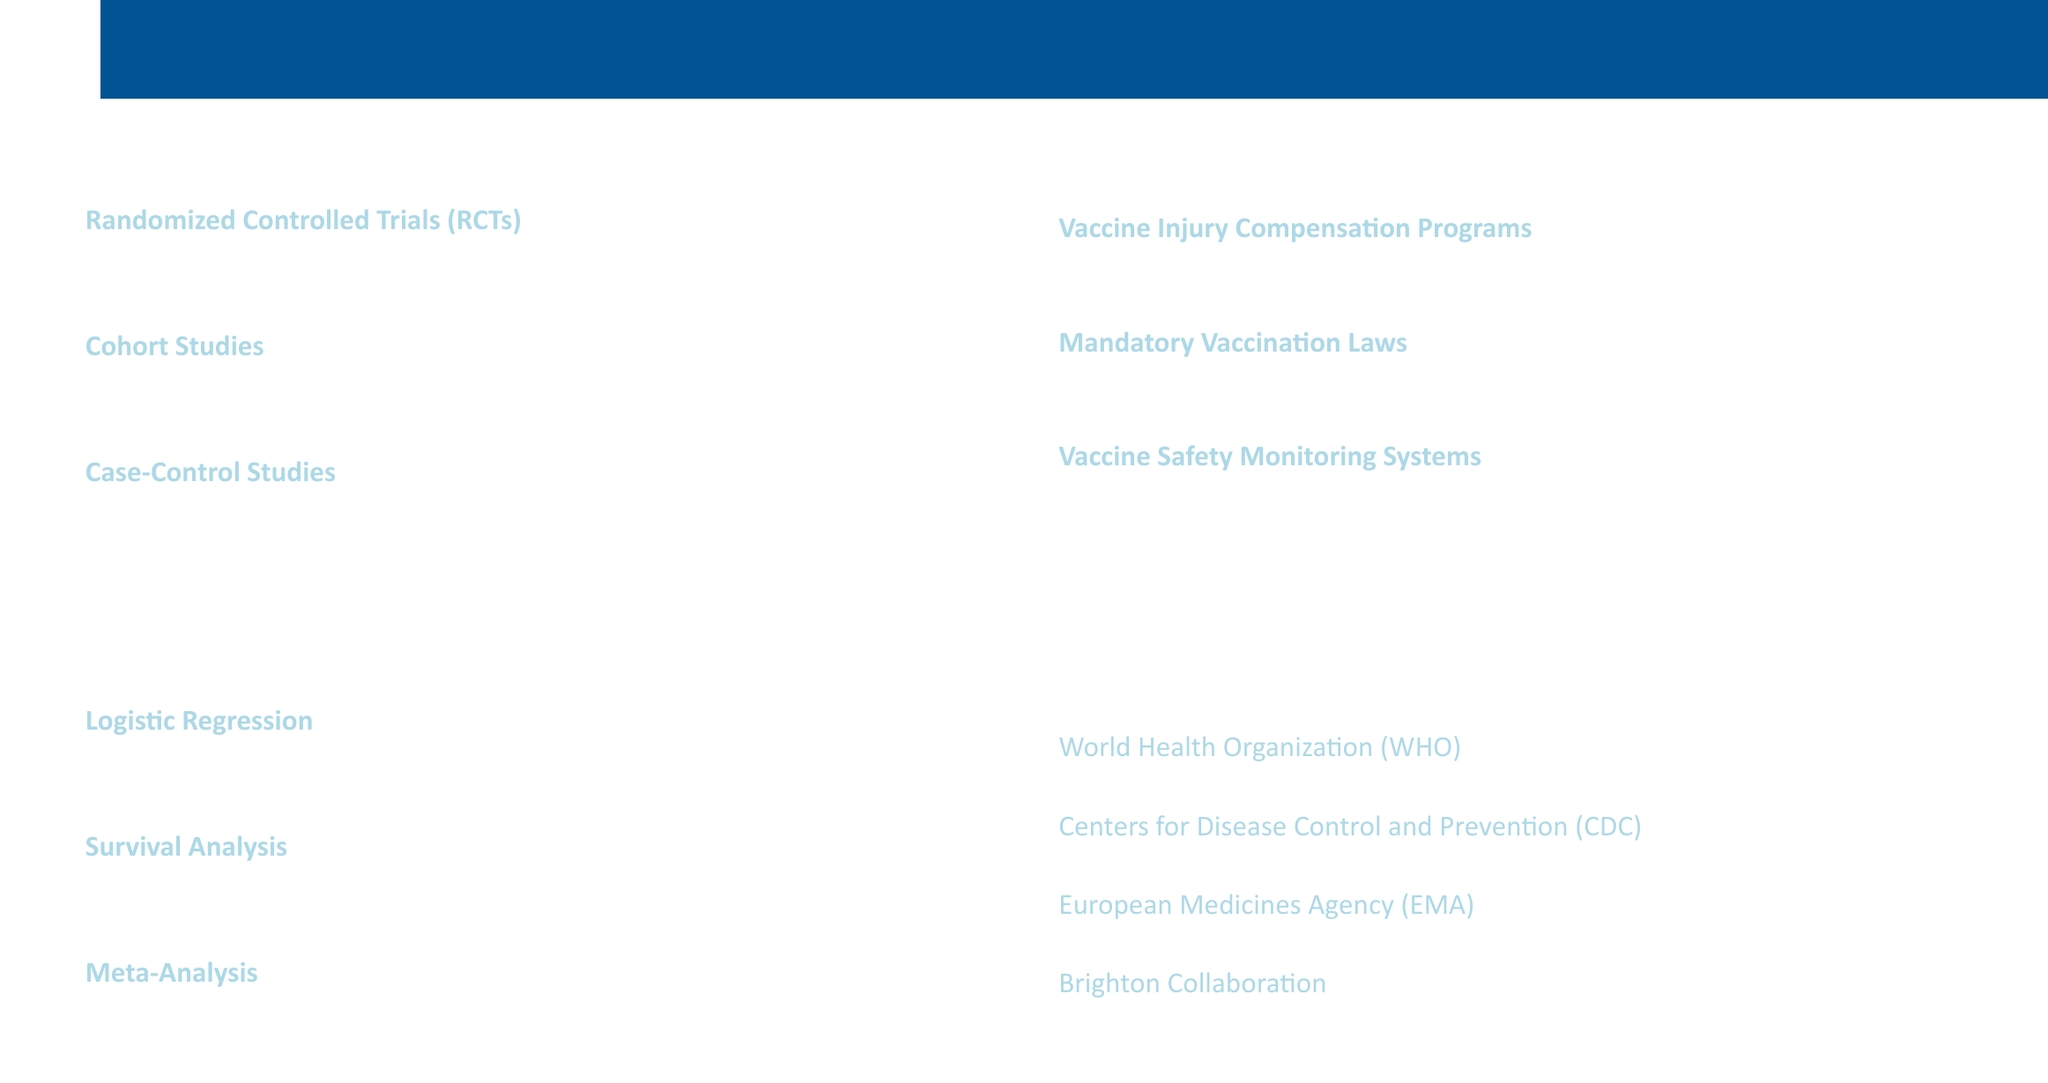What are the three methodologies listed? The methodologies include Randomized Controlled Trials, Cohort Studies, and Case-Control Studies.
Answer: Randomized Controlled Trials, Cohort Studies, Case-Control Studies What study is an example of a cohort study? The document provides an example of a cohort study focusing on long-term safety of measles-mumps-rubella vaccination.
Answer: Long-term Safety of Measles-Mumps-Rubella Vaccination: A Danish Cohort Study What statistical analysis is used to predict adverse events following immunization? The statistical analysis used for this application is Logistic Regression.
Answer: Logistic Regression Which software is mentioned for conducting survival analysis? The document specifies SAS (PROC PHREG) as the software to perform survival analysis.
Answer: SAS (PROC PHREG) How many key organizations are listed in the document? There are four key organizations provided in the document related to vaccine safety.
Answer: Four What compensation program is mentioned in policy implications? The document lists the National Vaccine Injury Compensation Program as an example of a compensation program.
Answer: National Vaccine Injury Compensation Program What is an example of a mandatory vaccination law mentioned? The document gives the School Entry Vaccination Requirements in Australia as an example of such a law.
Answer: School Entry Vaccination Requirements, Australia What type of analysis synthesizes results from multiple studies? The document refers to Meta-Analysis as a method for synthesizing results from multiple vaccine safety studies.
Answer: Meta-Analysis What is the focus of vaccine safety monitoring systems? The document lists the Vaccine Adverse Event Reporting System as an example of a vaccine safety monitoring system.
Answer: Vaccine Adverse Event Reporting System 